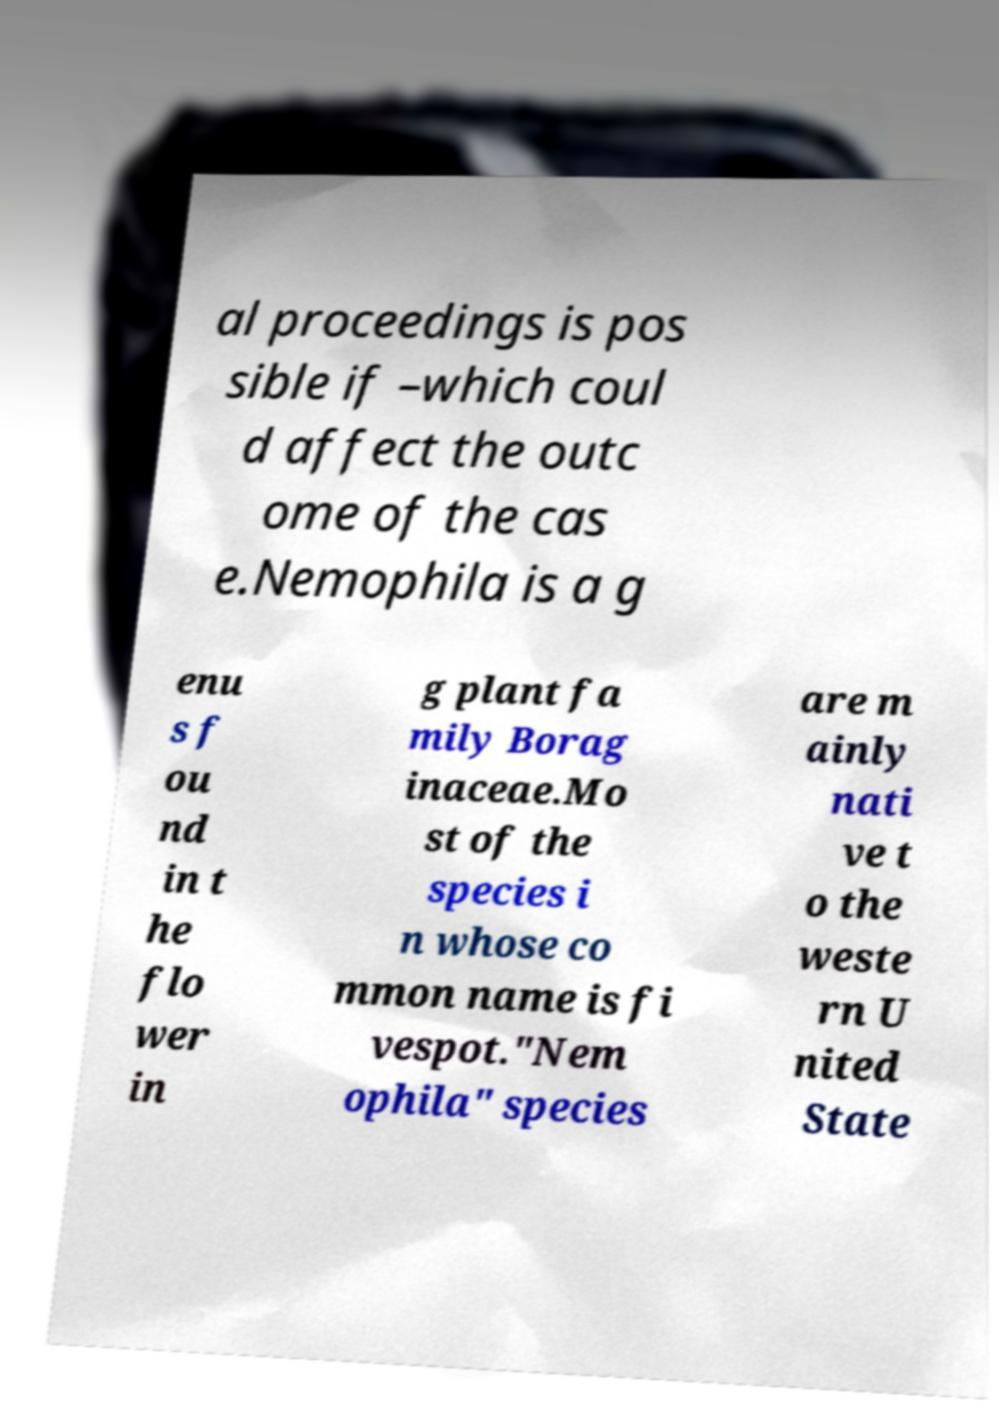There's text embedded in this image that I need extracted. Can you transcribe it verbatim? al proceedings is pos sible if –which coul d affect the outc ome of the cas e.Nemophila is a g enu s f ou nd in t he flo wer in g plant fa mily Borag inaceae.Mo st of the species i n whose co mmon name is fi vespot."Nem ophila" species are m ainly nati ve t o the weste rn U nited State 